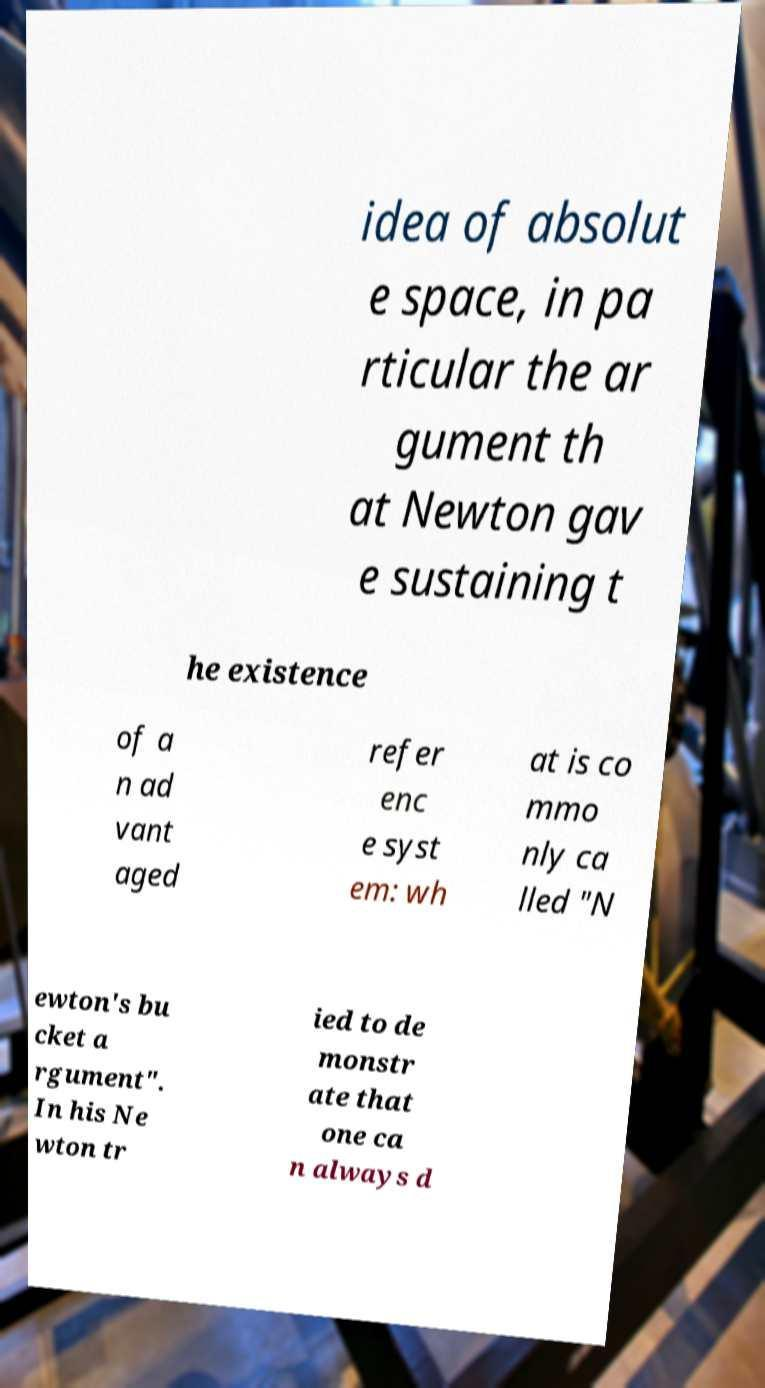What messages or text are displayed in this image? I need them in a readable, typed format. idea of absolut e space, in pa rticular the ar gument th at Newton gav e sustaining t he existence of a n ad vant aged refer enc e syst em: wh at is co mmo nly ca lled "N ewton's bu cket a rgument". In his Ne wton tr ied to de monstr ate that one ca n always d 